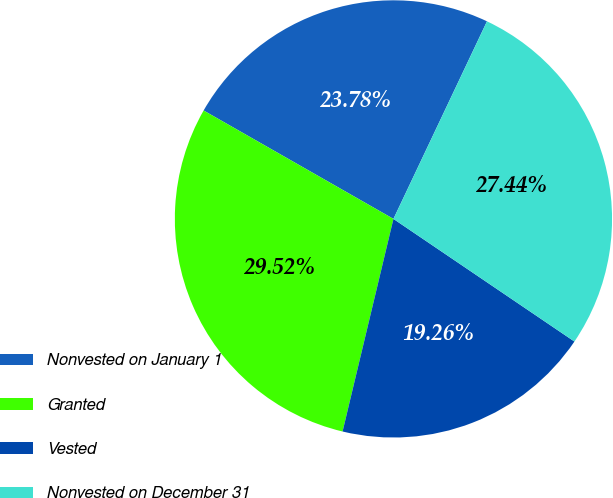Convert chart to OTSL. <chart><loc_0><loc_0><loc_500><loc_500><pie_chart><fcel>Nonvested on January 1<fcel>Granted<fcel>Vested<fcel>Nonvested on December 31<nl><fcel>23.78%<fcel>29.52%<fcel>19.26%<fcel>27.44%<nl></chart> 